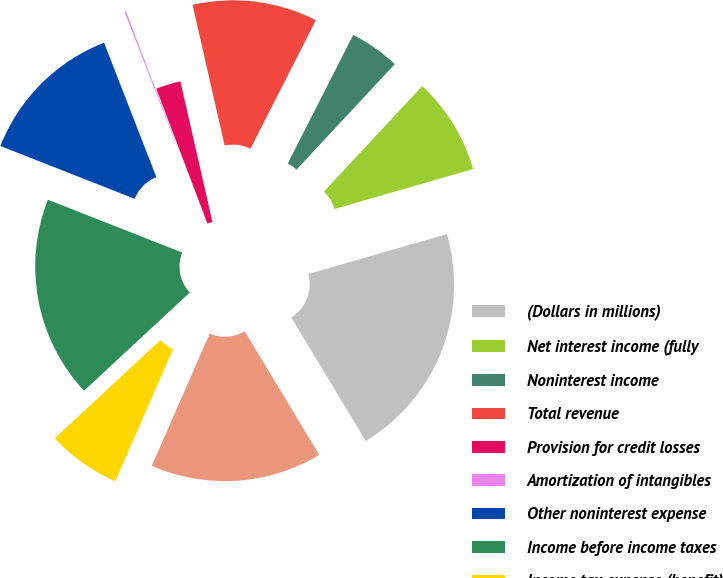<chart> <loc_0><loc_0><loc_500><loc_500><pie_chart><fcel>(Dollars in millions)<fcel>Net interest income (fully<fcel>Noninterest income<fcel>Total revenue<fcel>Provision for credit losses<fcel>Amortization of intangibles<fcel>Other noninterest expense<fcel>Income before income taxes<fcel>Income tax expense (benefit)<fcel>Net income<nl><fcel>20.83%<fcel>8.59%<fcel>4.45%<fcel>11.06%<fcel>2.2%<fcel>0.14%<fcel>13.13%<fcel>17.88%<fcel>6.52%<fcel>15.2%<nl></chart> 